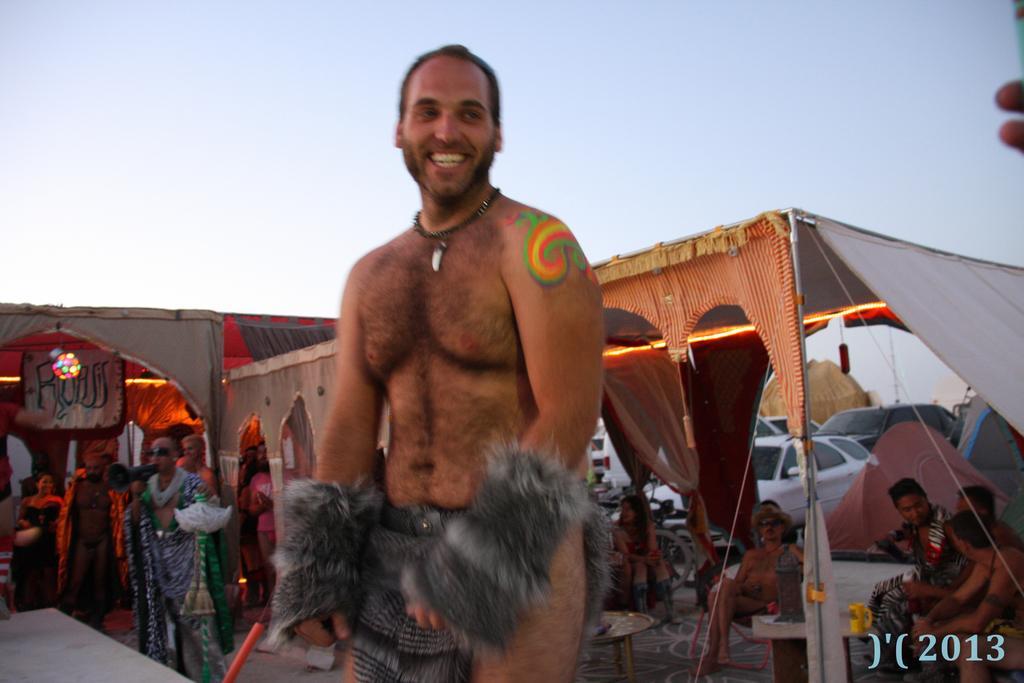Can you describe this image briefly? In this image in the front there is a man standing and smiling. In the background there are tents, cars and there are persons standing and sitting and there is a banner with some text written on it and there is a light which is visible. 